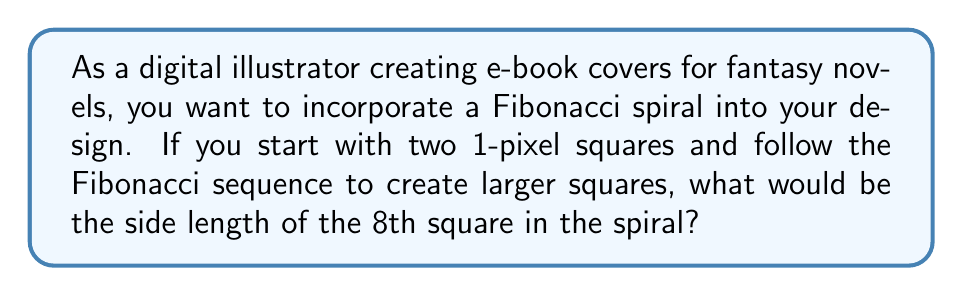Give your solution to this math problem. Let's approach this step-by-step:

1. Recall that the Fibonacci sequence is defined as:
   $$F_n = F_{n-1} + F_{n-2}$$
   where $F_1 = F_2 = 1$

2. Let's calculate the first 8 terms of the sequence:
   $F_1 = 1$
   $F_2 = 1$
   $F_3 = F_2 + F_1 = 1 + 1 = 2$
   $F_4 = F_3 + F_2 = 2 + 1 = 3$
   $F_5 = F_4 + F_3 = 3 + 2 = 5$
   $F_6 = F_5 + F_4 = 5 + 3 = 8$
   $F_7 = F_6 + F_5 = 8 + 5 = 13$
   $F_8 = F_7 + F_6 = 13 + 8 = 21$

3. In the Fibonacci spiral, each square's side length corresponds to a term in the Fibonacci sequence.

4. The 8th square in the spiral corresponds to the 8th term in the Fibonacci sequence, which we calculated as 21.

Therefore, the side length of the 8th square in the Fibonacci spiral would be 21 pixels.
Answer: 21 pixels 